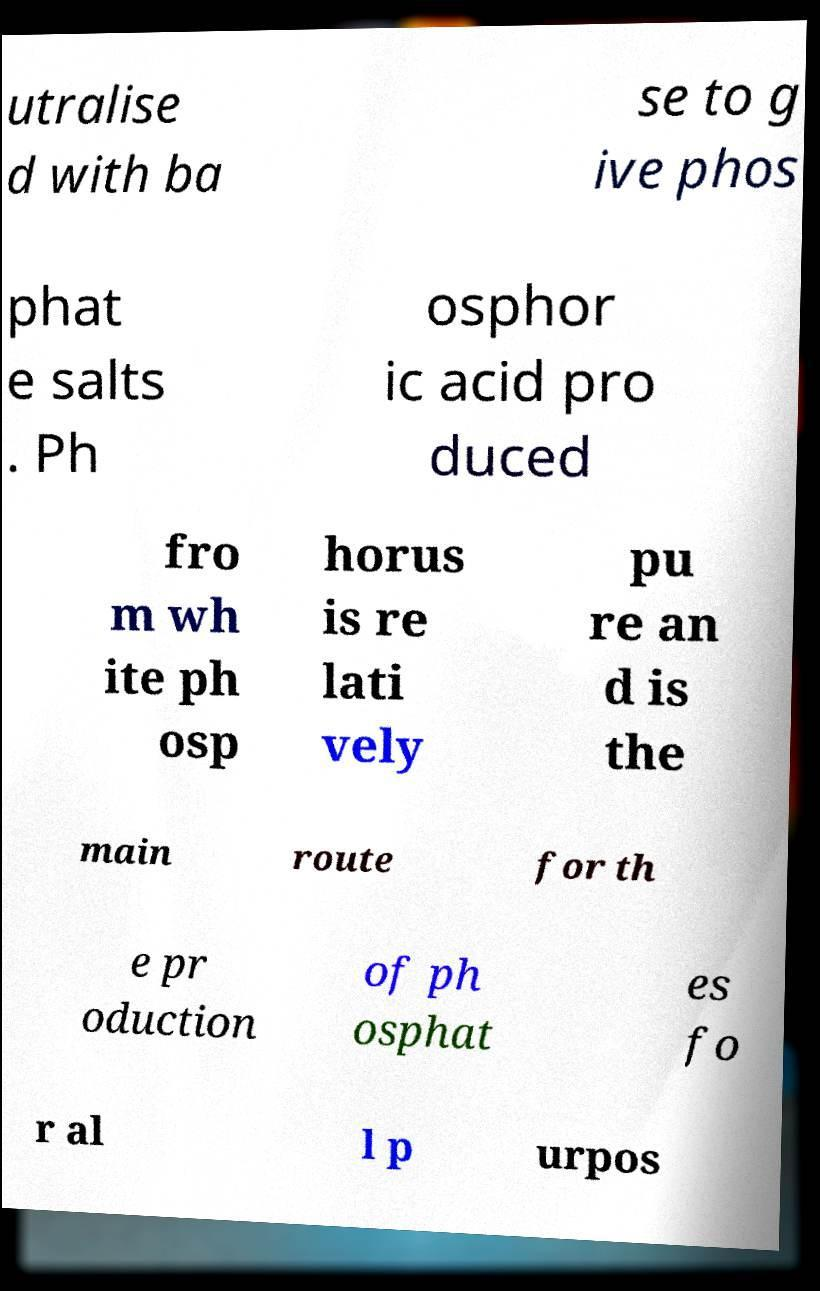I need the written content from this picture converted into text. Can you do that? utralise d with ba se to g ive phos phat e salts . Ph osphor ic acid pro duced fro m wh ite ph osp horus is re lati vely pu re an d is the main route for th e pr oduction of ph osphat es fo r al l p urpos 